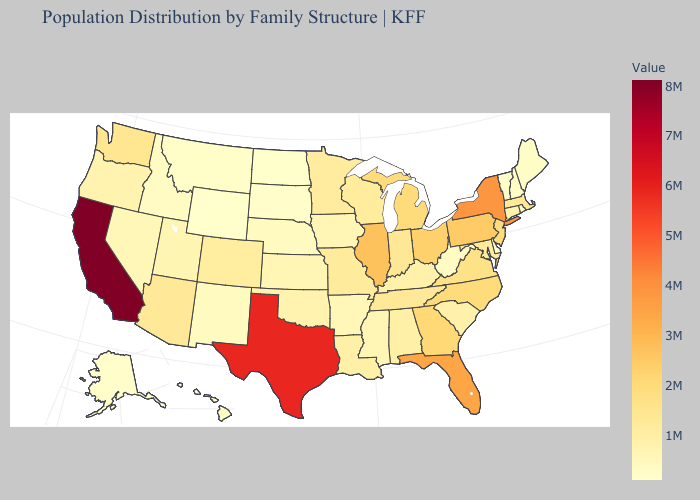Which states hav the highest value in the MidWest?
Answer briefly. Illinois. Does Nevada have the lowest value in the USA?
Write a very short answer. No. Which states have the lowest value in the USA?
Give a very brief answer. Vermont. Which states have the lowest value in the West?
Be succinct. Wyoming. Is the legend a continuous bar?
Give a very brief answer. Yes. Which states have the highest value in the USA?
Concise answer only. California. Among the states that border Rhode Island , which have the highest value?
Give a very brief answer. Massachusetts. 